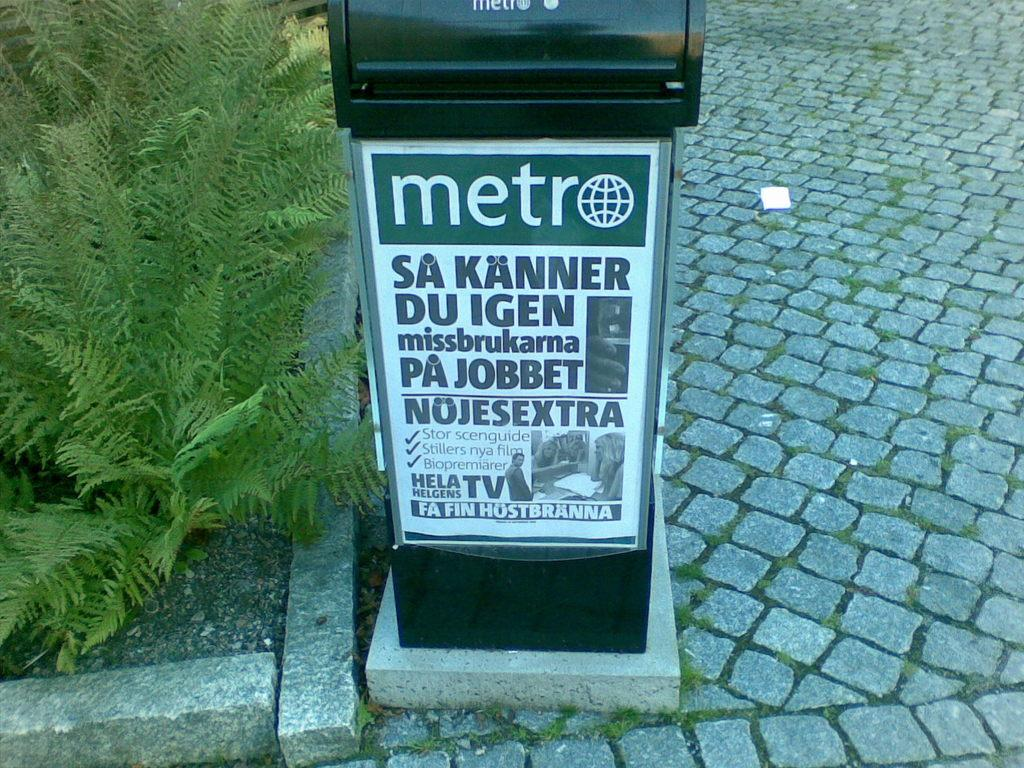<image>
Offer a succinct explanation of the picture presented. A newspaper receptacle sits on a stone sidewalk. 